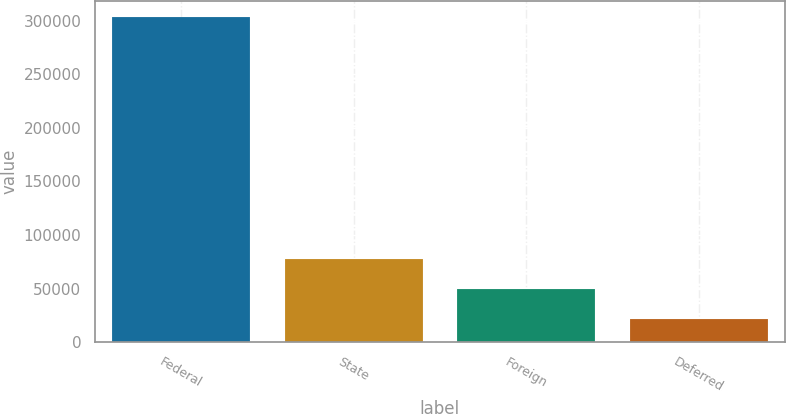Convert chart to OTSL. <chart><loc_0><loc_0><loc_500><loc_500><bar_chart><fcel>Federal<fcel>State<fcel>Foreign<fcel>Deferred<nl><fcel>303016<fcel>77900.8<fcel>49761.4<fcel>21622<nl></chart> 